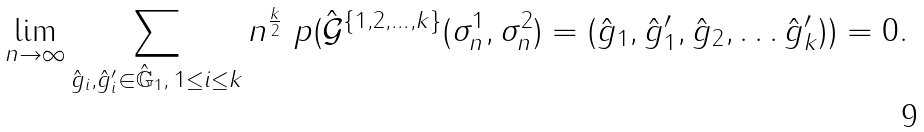<formula> <loc_0><loc_0><loc_500><loc_500>\lim _ { n \to \infty } \sum _ { \substack { \hat { g } _ { i } , \hat { g } ^ { \prime } _ { i } \in \hat { \mathbb { G } } _ { 1 } , \, 1 \leq i \leq k } } n ^ { \frac { k } { 2 } } \ p ( \hat { \mathcal { G } } ^ { \{ 1 , 2 , \dots , k \} } ( \sigma ^ { 1 } _ { n } , \sigma ^ { 2 } _ { n } ) = ( \hat { g } _ { 1 } , \hat { g } ^ { \prime } _ { 1 } , \hat { g } _ { 2 } , \dots \hat { g } ^ { \prime } _ { k } ) ) = 0 .</formula> 